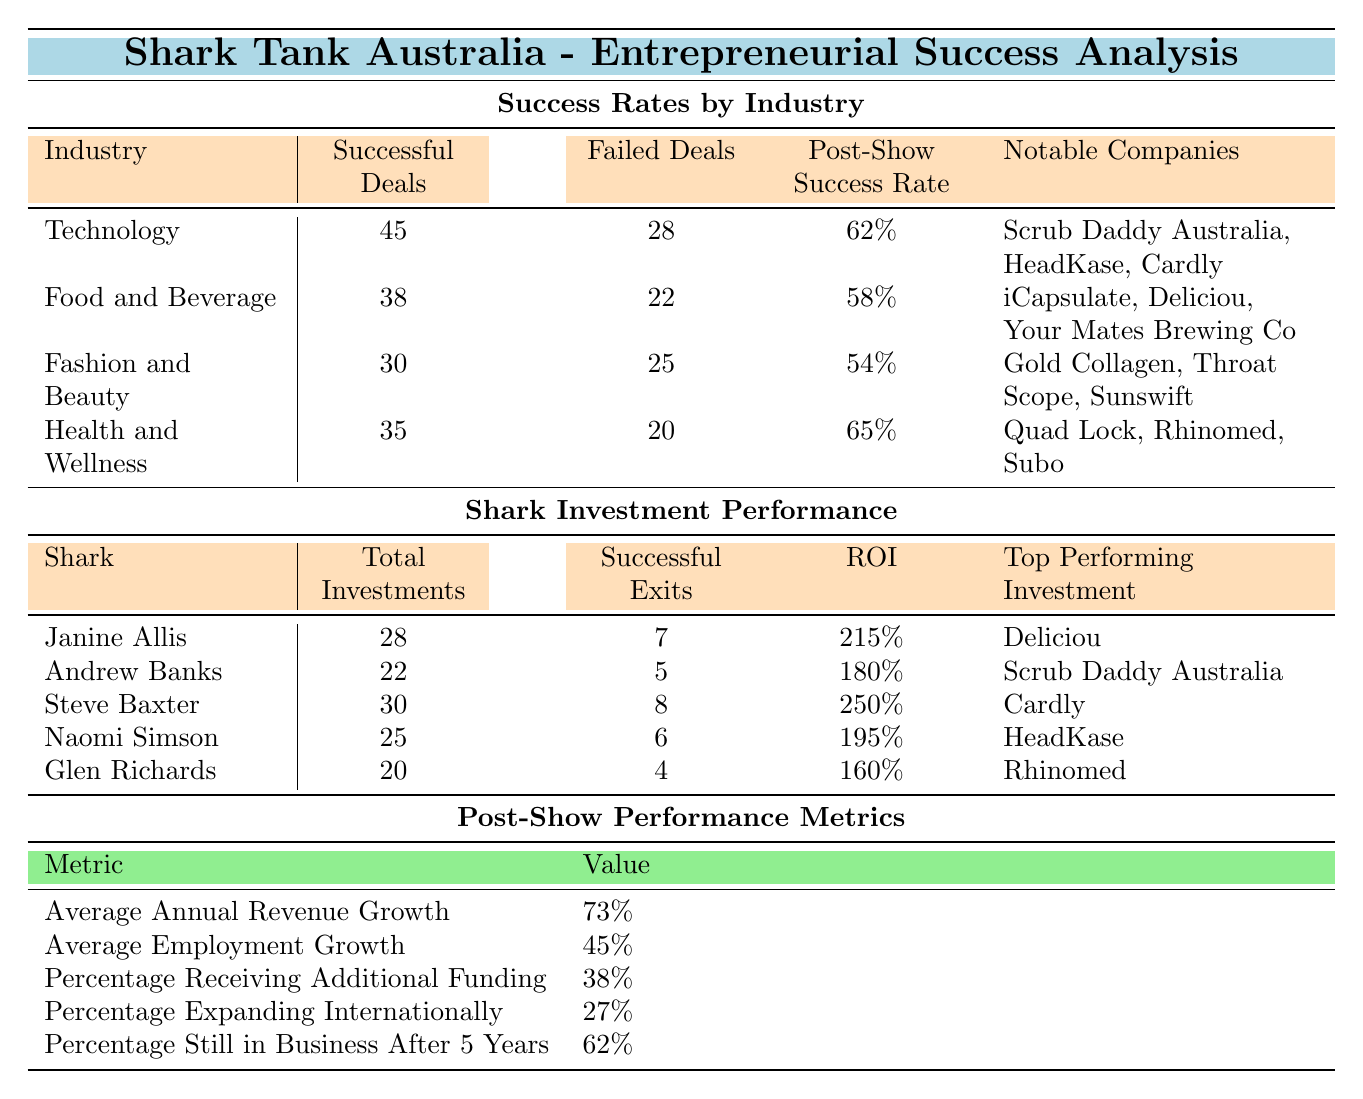What is the post-show success rate for the Health and Wellness industry? The table lists the post-show success rates by industry, and for Health and Wellness, the value is directly provided as 65%.
Answer: 65% Which industry has the highest number of successful deals? By comparing the successful deals across all industries, Technology has the highest with 45 successful deals.
Answer: Technology How many total investments did Steve Baxter make? The table shows that Steve Baxter made a total of 30 investments.
Answer: 30 What is the ROI of Janine Allis's investments? The ROI for Janine Allis is found in the Shark Investment Performance section, specifically noted as 215%.
Answer: 215% Which industry has the lowest post-show success rate? A comparison of the post-show success rates reveals that Fashion and Beauty has the lowest at 54%.
Answer: Fashion and Beauty What is the difference in successful deals between Technology and Food and Beverage? Technology has 45 successful deals and Food and Beverage has 38; thus, the difference is 45 - 38 = 7.
Answer: 7 Did Glen Richards have a higher ROI than Naomi Simson? Glen Richards's ROI is 160%, while Naomi Simson's is 195%. Since 160% is less than 195%, Glen Richards did not have a higher ROI.
Answer: No What percentage of companies in the Health and Wellness industry are still in business after 5 years? The relevant metric for company longevity is provided as 62% for companies still in business after 5 years.
Answer: 62% What is the total number of successful exits from all Sharks combined? Adding the successful exits of all Sharks: 7 (Janine) + 5 (Andrew) + 8 (Steve) + 6 (Naomi) + 4 (Glen) gives a total of 30 successful exits.
Answer: 30 Which notable company from the Food and Beverage industry had success on Shark Tank? The notable companies listed under Food and Beverage include iCapsulate, Deliciou, and Your Mates Brewing Co; any of these can be an answer.
Answer: Deliciou 